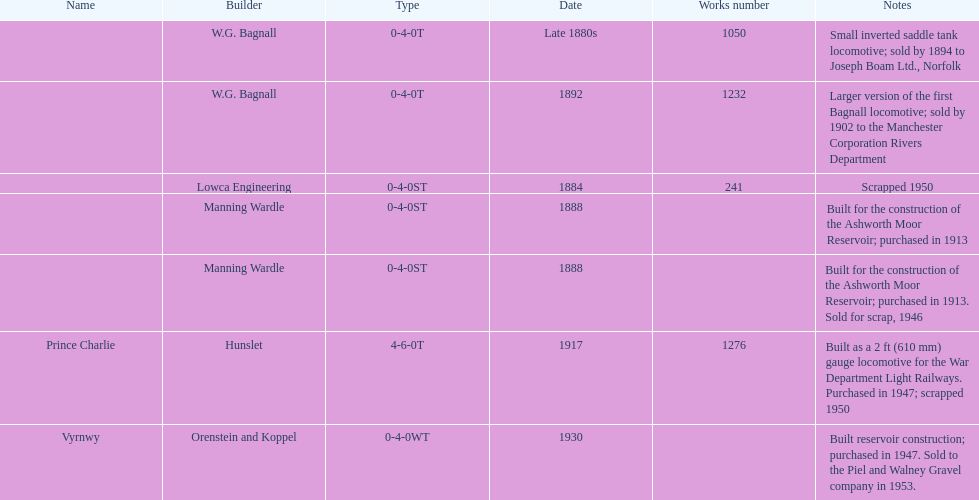How many locomotives were built for the construction of the ashworth moor reservoir? 2. 